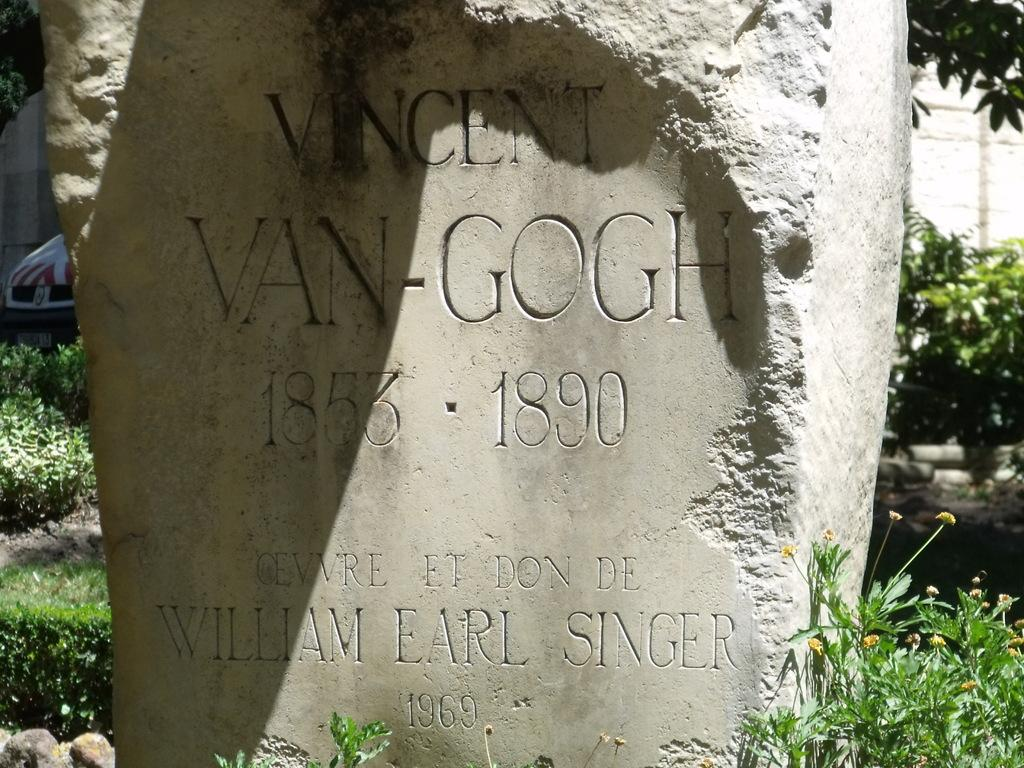What is the main subject of the image? There is a grave in the image. What is located near the grave? The grave is near plants. What type of plants are present in the image? The plants have flowers. Can you describe the background of the image? There are plants and a tree in the background, and grass is present on the ground. How does the rod start moving in the image? There is no rod present in the image, so it cannot start moving. 